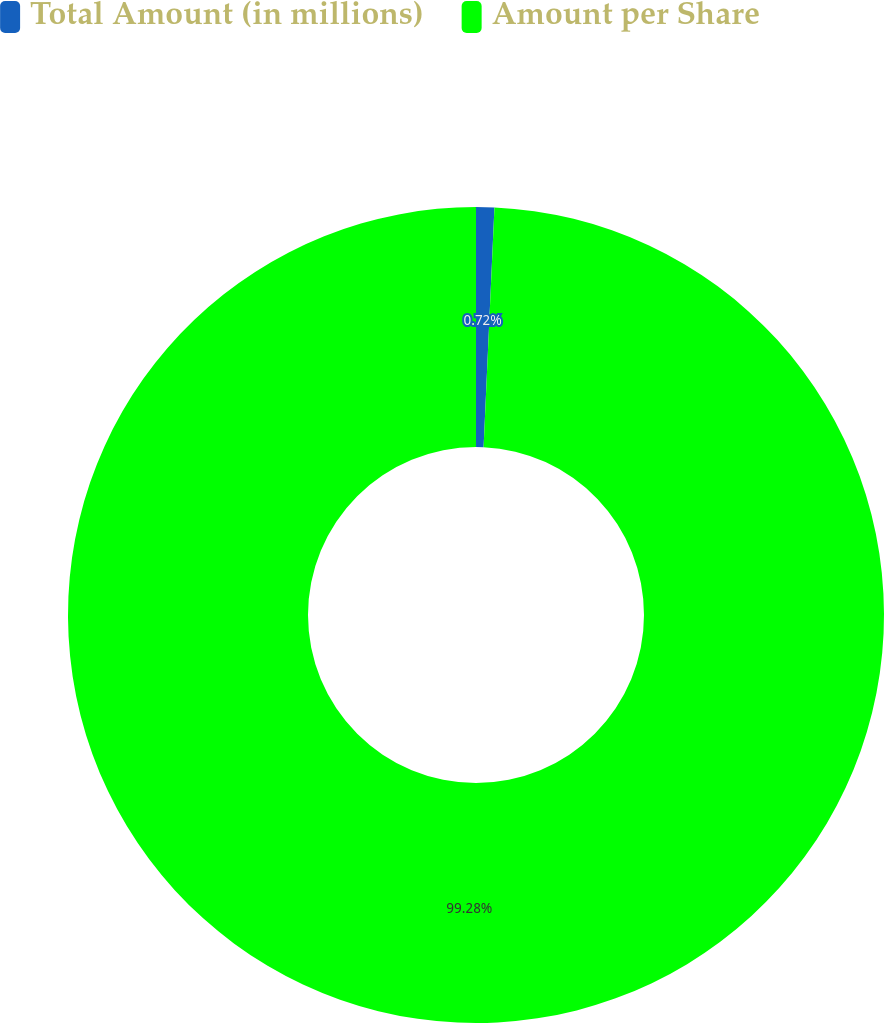Convert chart to OTSL. <chart><loc_0><loc_0><loc_500><loc_500><pie_chart><fcel>Total Amount (in millions)<fcel>Amount per Share<nl><fcel>0.72%<fcel>99.28%<nl></chart> 